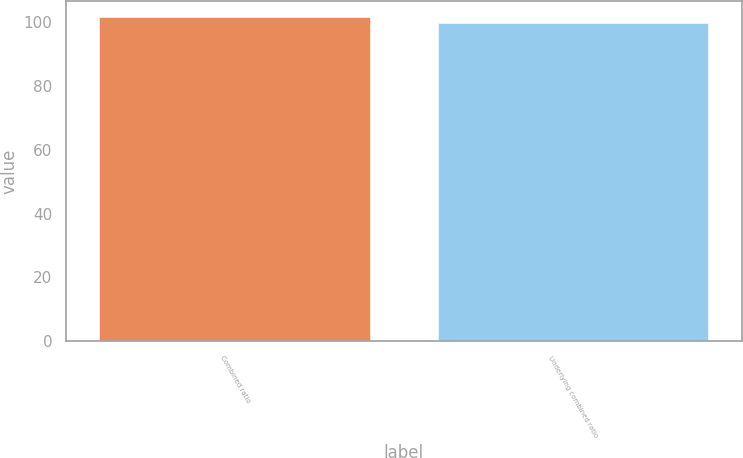Convert chart. <chart><loc_0><loc_0><loc_500><loc_500><bar_chart><fcel>Combined ratio<fcel>Underlying combined ratio<nl><fcel>101.6<fcel>99.7<nl></chart> 